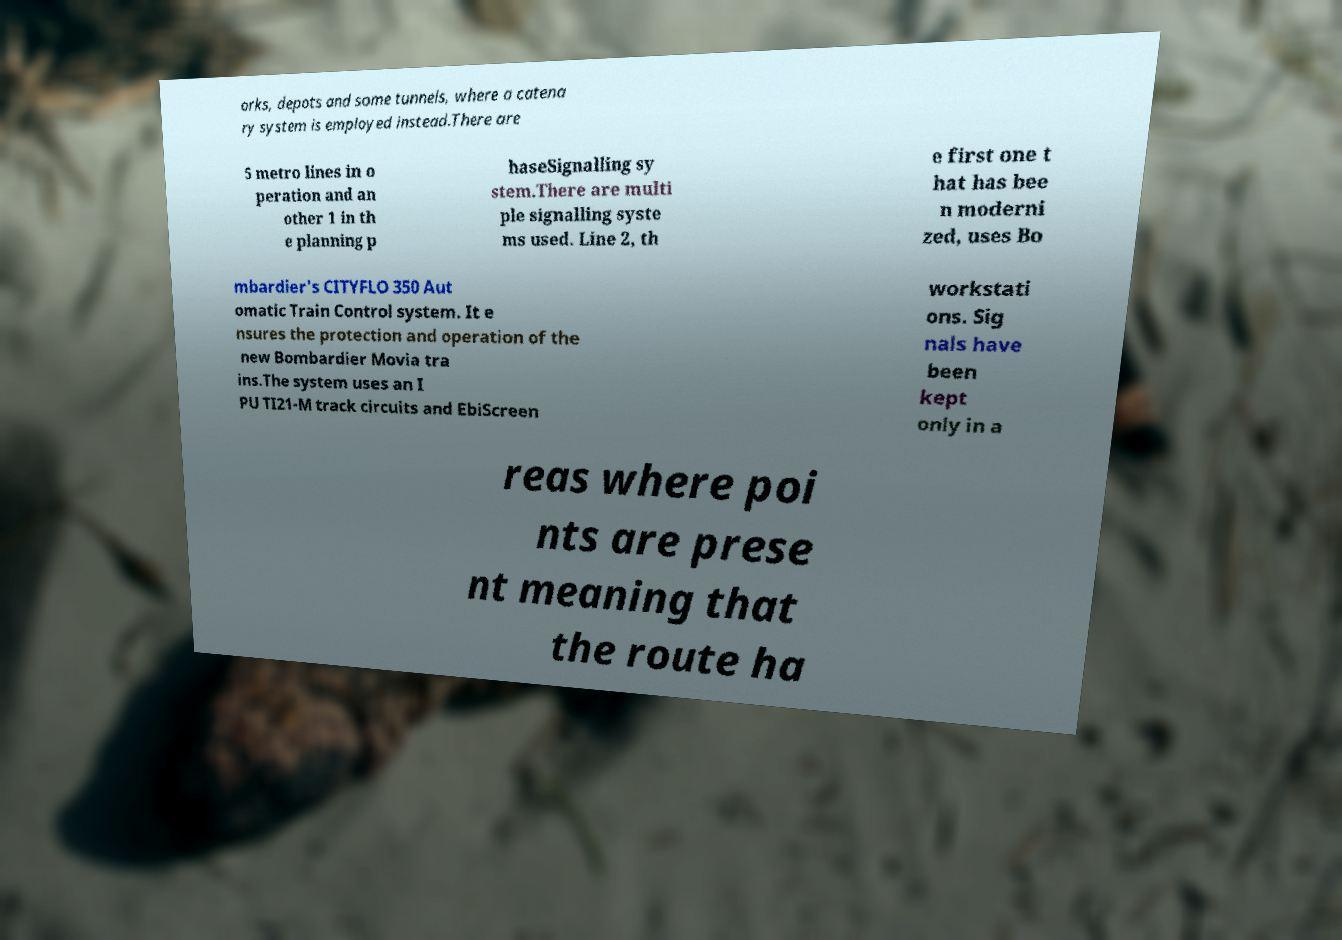Can you accurately transcribe the text from the provided image for me? orks, depots and some tunnels, where a catena ry system is employed instead.There are 5 metro lines in o peration and an other 1 in th e planning p haseSignalling sy stem.There are multi ple signalling syste ms used. Line 2, th e first one t hat has bee n moderni zed, uses Bo mbardier's CITYFLO 350 Aut omatic Train Control system. It e nsures the protection and operation of the new Bombardier Movia tra ins.The system uses an I PU TI21-M track circuits and EbiScreen workstati ons. Sig nals have been kept only in a reas where poi nts are prese nt meaning that the route ha 